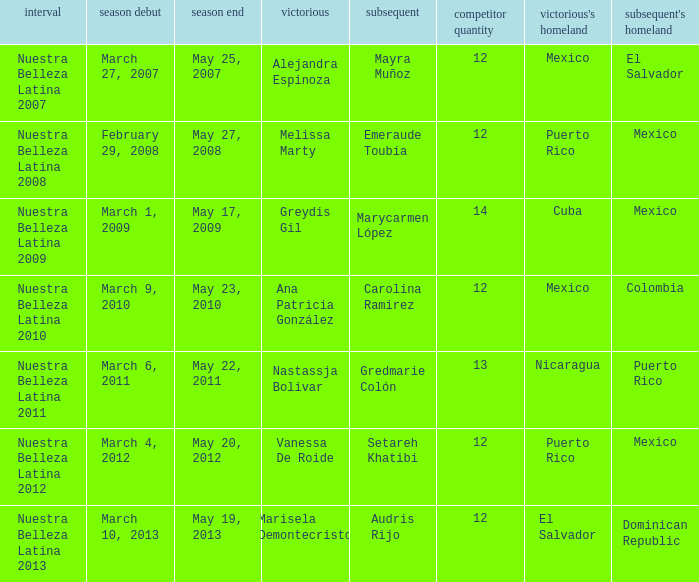What season had mexico as the runner up with melissa marty winning? Nuestra Belleza Latina 2008. 